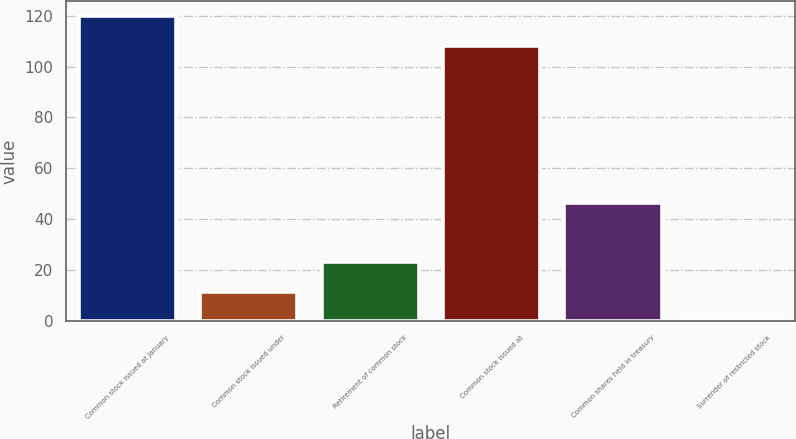Convert chart. <chart><loc_0><loc_0><loc_500><loc_500><bar_chart><fcel>Common stock issued at January<fcel>Common stock issued under<fcel>Retirement of common stock<fcel>Common stock issued at<fcel>Common shares held in treasury<fcel>Surrender of restricted stock<nl><fcel>119.67<fcel>11.67<fcel>23.24<fcel>108.1<fcel>46.38<fcel>0.1<nl></chart> 